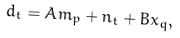Convert formula to latex. <formula><loc_0><loc_0><loc_500><loc_500>d _ { t } = A m _ { p } + n _ { t } + B x _ { q } ,</formula> 